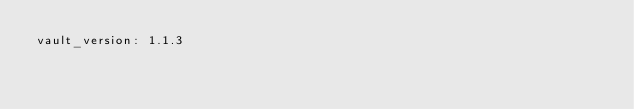<code> <loc_0><loc_0><loc_500><loc_500><_YAML_>vault_version: 1.1.3
</code> 